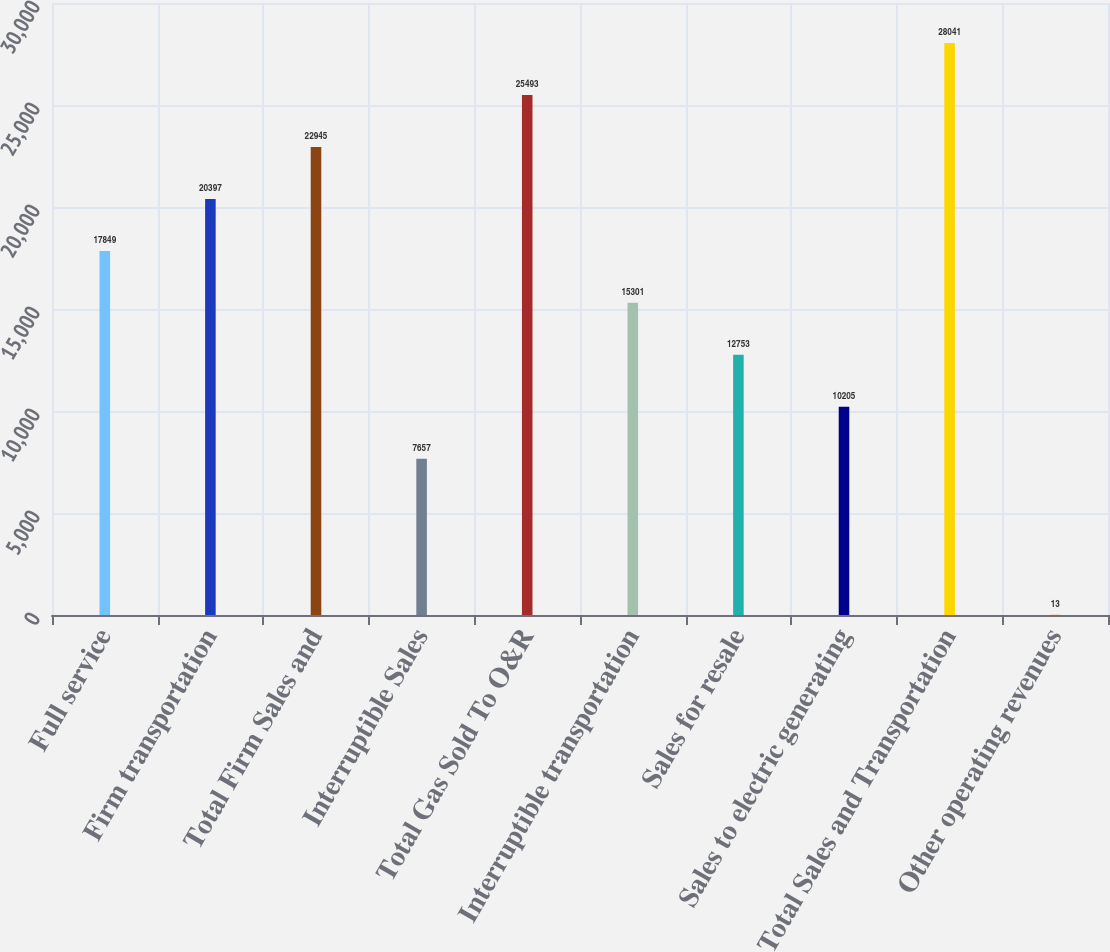Convert chart. <chart><loc_0><loc_0><loc_500><loc_500><bar_chart><fcel>Full service<fcel>Firm transportation<fcel>Total Firm Sales and<fcel>Interruptible Sales<fcel>Total Gas Sold To O&R<fcel>Interruptible transportation<fcel>Sales for resale<fcel>Sales to electric generating<fcel>Total Sales and Transportation<fcel>Other operating revenues<nl><fcel>17849<fcel>20397<fcel>22945<fcel>7657<fcel>25493<fcel>15301<fcel>12753<fcel>10205<fcel>28041<fcel>13<nl></chart> 